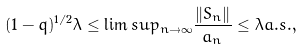<formula> <loc_0><loc_0><loc_500><loc_500>( 1 - q ) ^ { 1 / 2 } \lambda \leq \lim s u p _ { n \rightarrow \infty } \frac { \| S _ { n } \| } { a _ { n } } \leq \lambda a . s . ,</formula> 